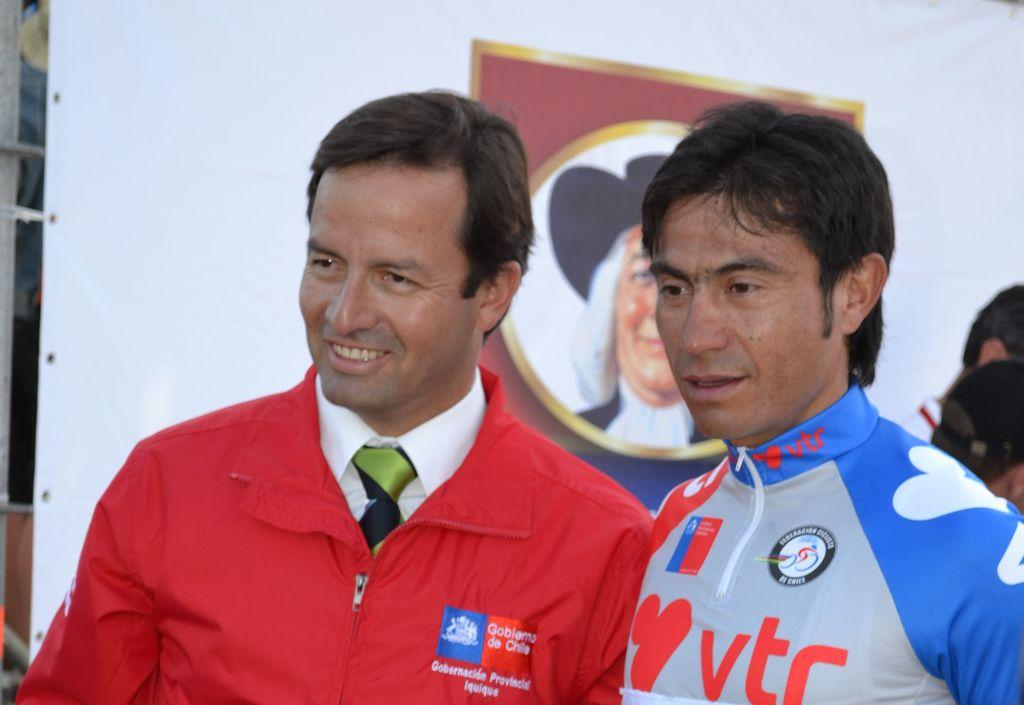<image>
Write a terse but informative summary of the picture. Man with a red jacket on that has Goblemo de Chile on the left side in white lettering. 